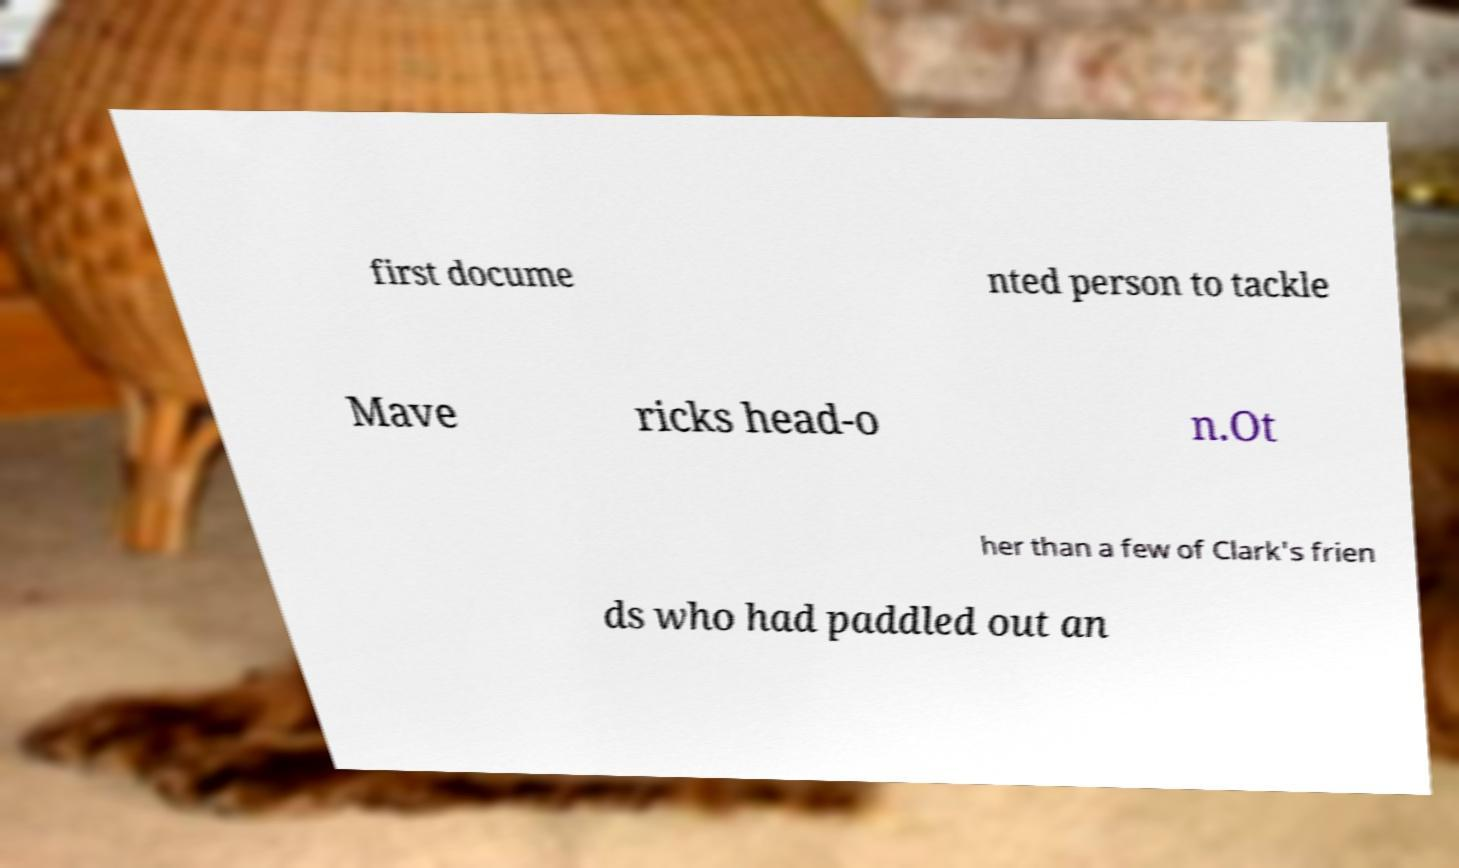Can you accurately transcribe the text from the provided image for me? first docume nted person to tackle Mave ricks head-o n.Ot her than a few of Clark's frien ds who had paddled out an 